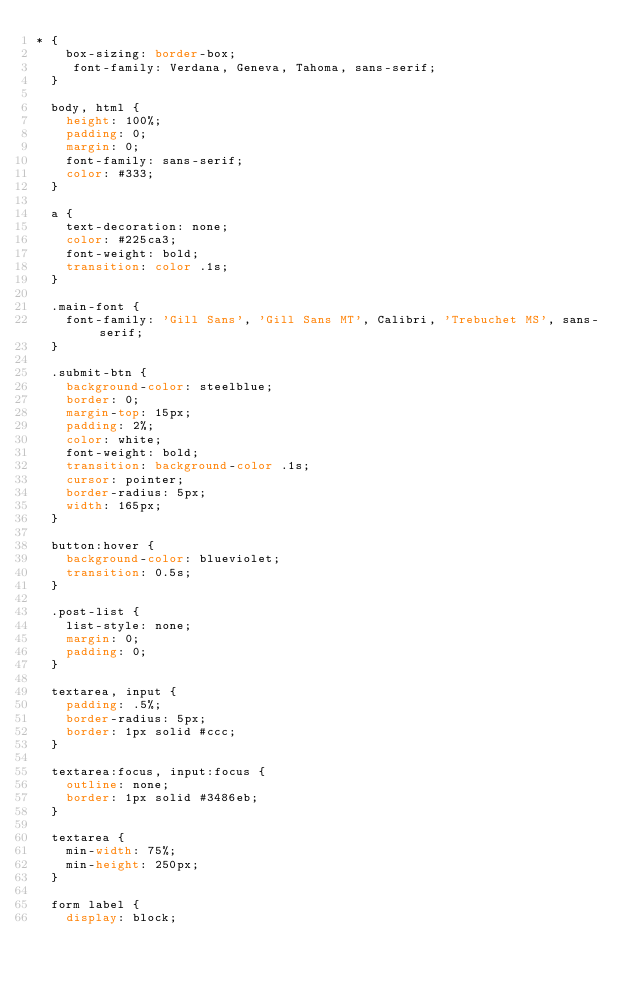<code> <loc_0><loc_0><loc_500><loc_500><_CSS_>* {
    box-sizing: border-box;
     font-family: Verdana, Geneva, Tahoma, sans-serif;
  }
  
  body, html {
    height: 100%;
    padding: 0;
    margin: 0;
    font-family: sans-serif;
    color: #333;
  }
  
  a {
    text-decoration: none;
    color: #225ca3;
    font-weight: bold;
    transition: color .1s;
  }
  
  .main-font {
    font-family: 'Gill Sans', 'Gill Sans MT', Calibri, 'Trebuchet MS', sans-serif;
  }
  
  .submit-btn {
    background-color: steelblue;
    border: 0;
    margin-top: 15px;
    padding: 2%;
    color: white;
    font-weight: bold;
    transition: background-color .1s;
    cursor: pointer;
    border-radius: 5px;
    width: 165px;
  }
  
  button:hover {
    background-color: blueviolet;
    transition: 0.5s;
  }
  
  .post-list {
    list-style: none;
    margin: 0;
    padding: 0;
  }
  
  textarea, input {
    padding: .5%;
    border-radius: 5px;
    border: 1px solid #ccc;
  }
  
  textarea:focus, input:focus {
    outline: none;
    border: 1px solid #3486eb;
  }
  
  textarea {
    min-width: 75%;
    min-height: 250px;
  }
  
  form label {
    display: block;</code> 